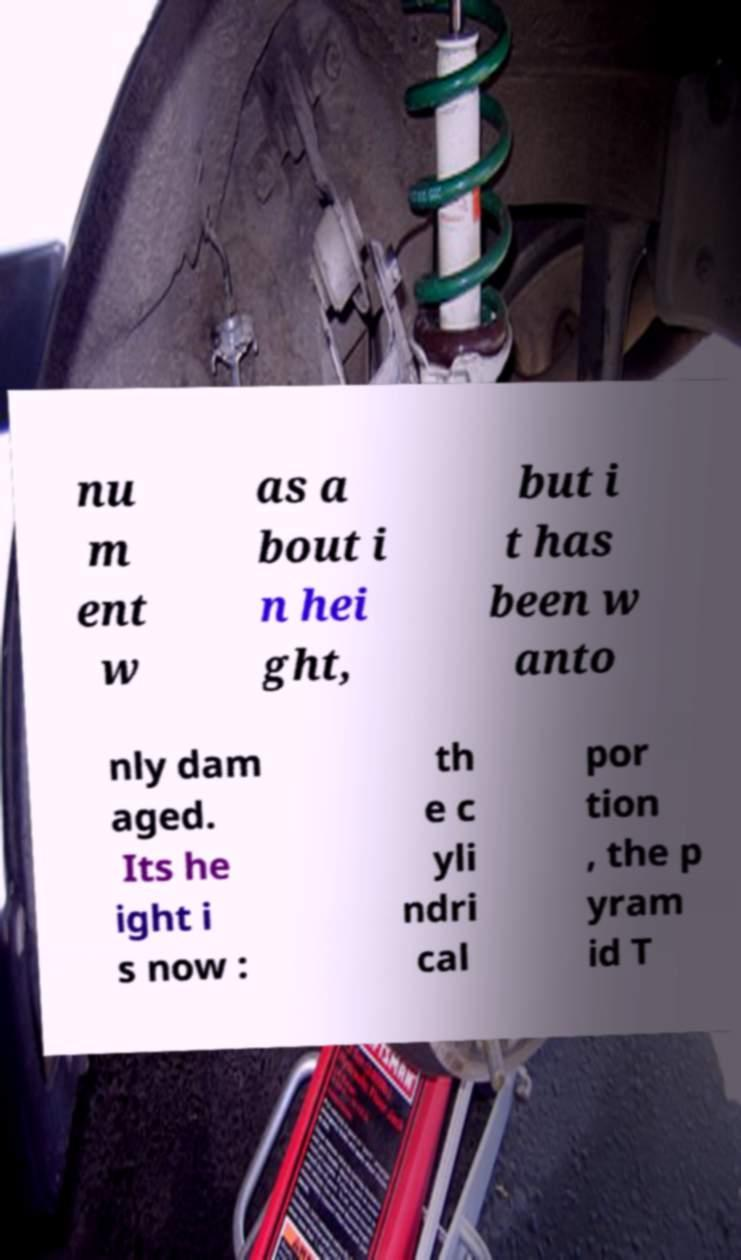Can you accurately transcribe the text from the provided image for me? nu m ent w as a bout i n hei ght, but i t has been w anto nly dam aged. Its he ight i s now : th e c yli ndri cal por tion , the p yram id T 